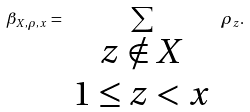<formula> <loc_0><loc_0><loc_500><loc_500>\beta _ { X , \rho , x } = \sum _ { \begin{array} { c } z \notin X \\ 1 \leq z < x \end{array} } \rho _ { z } .</formula> 